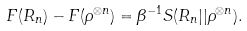<formula> <loc_0><loc_0><loc_500><loc_500>F ( R _ { n } ) - F ( \rho ^ { \otimes n } ) = \beta ^ { - 1 } S ( R _ { n } | | \rho ^ { \otimes n } ) .</formula> 